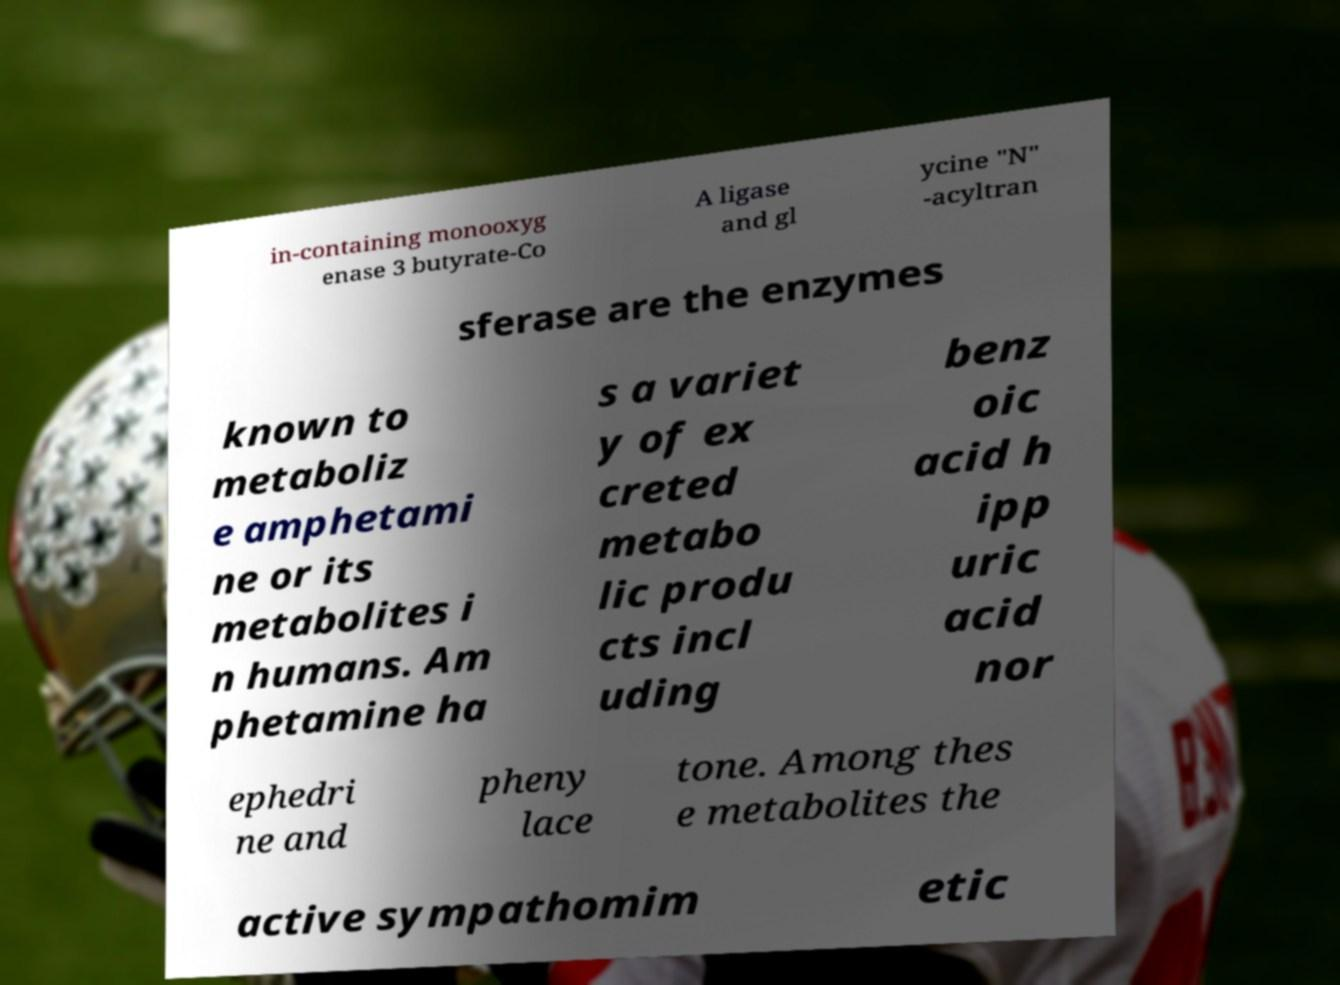Could you extract and type out the text from this image? in-containing monooxyg enase 3 butyrate-Co A ligase and gl ycine "N" -acyltran sferase are the enzymes known to metaboliz e amphetami ne or its metabolites i n humans. Am phetamine ha s a variet y of ex creted metabo lic produ cts incl uding benz oic acid h ipp uric acid nor ephedri ne and pheny lace tone. Among thes e metabolites the active sympathomim etic 